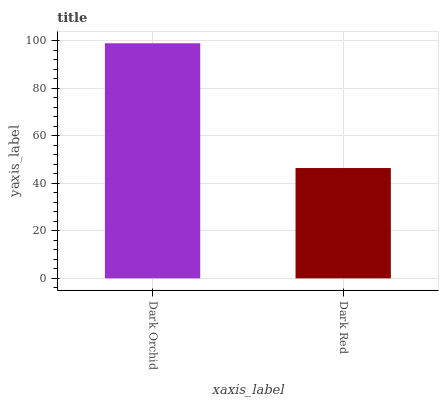Is Dark Red the minimum?
Answer yes or no. Yes. Is Dark Orchid the maximum?
Answer yes or no. Yes. Is Dark Red the maximum?
Answer yes or no. No. Is Dark Orchid greater than Dark Red?
Answer yes or no. Yes. Is Dark Red less than Dark Orchid?
Answer yes or no. Yes. Is Dark Red greater than Dark Orchid?
Answer yes or no. No. Is Dark Orchid less than Dark Red?
Answer yes or no. No. Is Dark Orchid the high median?
Answer yes or no. Yes. Is Dark Red the low median?
Answer yes or no. Yes. Is Dark Red the high median?
Answer yes or no. No. Is Dark Orchid the low median?
Answer yes or no. No. 